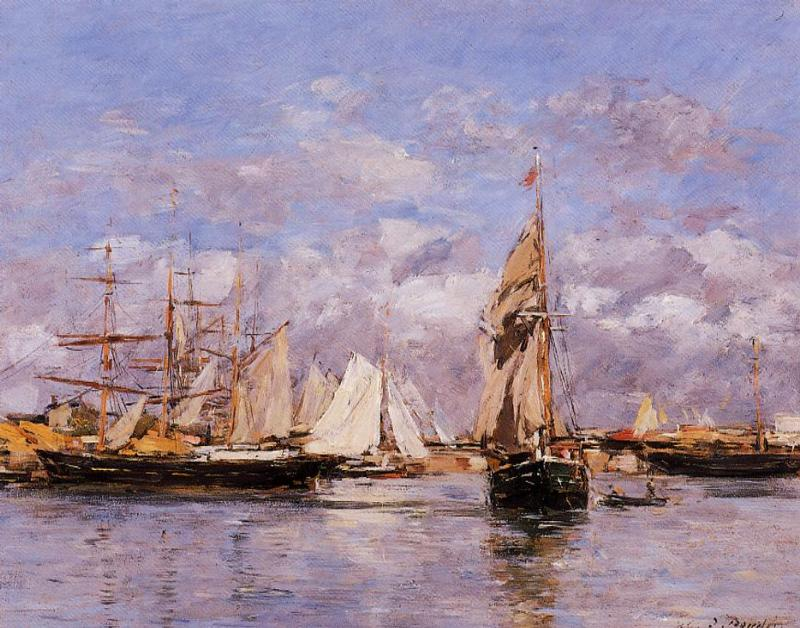Explain the visual content of the image in great detail.
 This image is a beautiful representation of an impressionist painting. The scene is set in a harbor, bustling with a variety of boats and ships. A large sailboat takes center stage in the foreground, while several smaller boats can be seen in the distance. The background is adorned with buildings, perhaps indicative of a nearby town or city, under a sky filled with clouds.

The artist has employed a loose, sketchy style, focusing on the interplay of colors and light rather than intricate details. The color palette is dominated by pastel blues, pinks, and yellows, creating a soft, serene atmosphere. However, darker tones are also present, adding depth and contrast to the boats and buildings.

The art genre is unmistakably impressionism, characterized by its emphasis on capturing the fleeting effects of light and color. It's a style that seeks to convey the impression of a scene, rather than a detailed, realistic representation. This painting beautifully embodies these principles, offering a glimpse into a tranquil harbor scene through the lens of impressionism. 